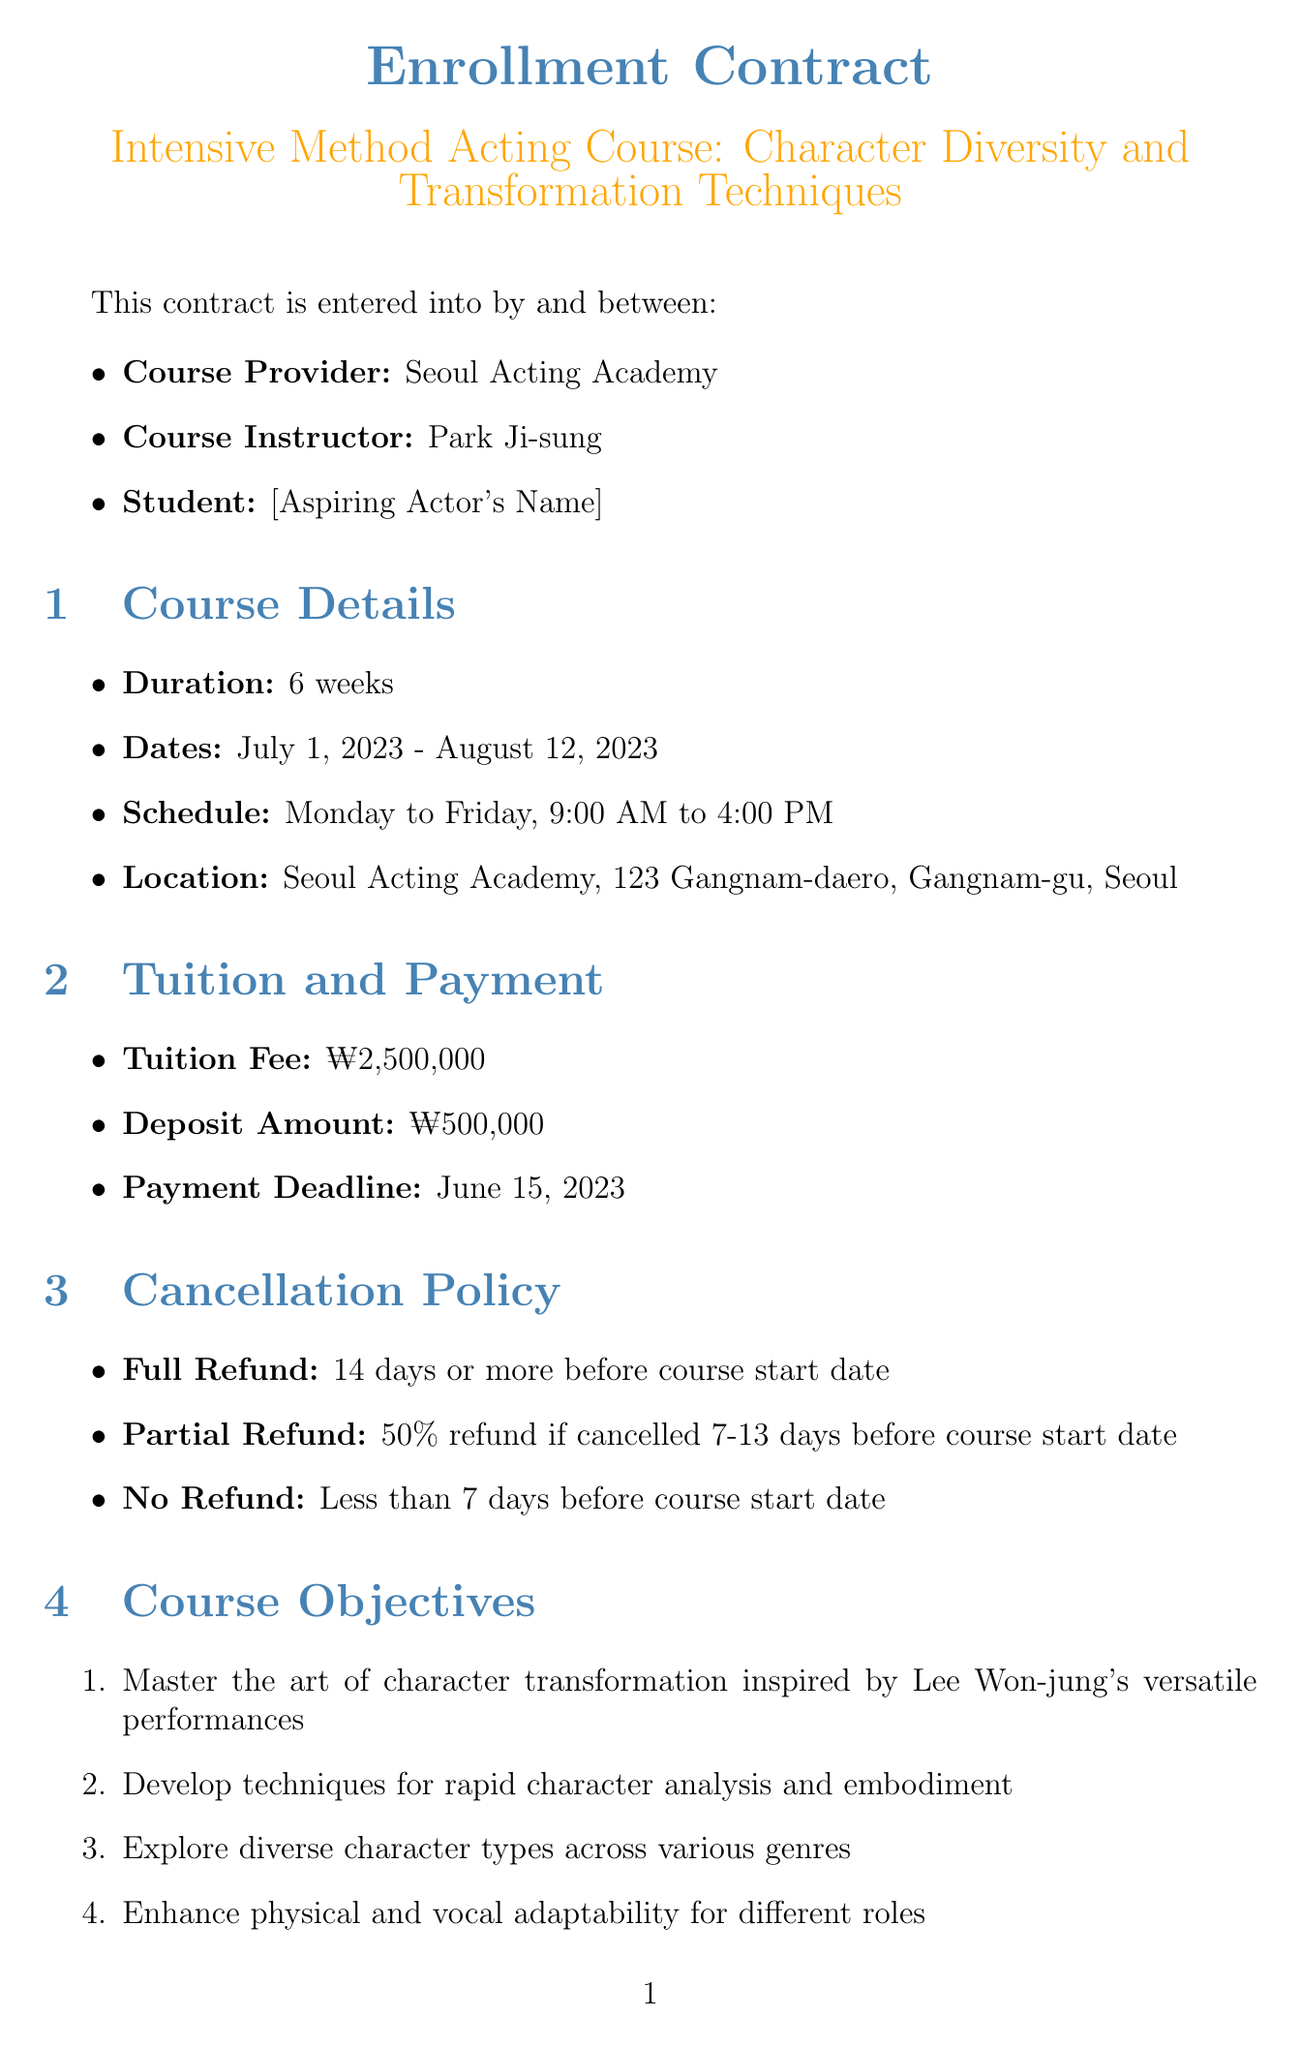What is the course provider? The document specifies that the course provider is the Seoul Acting Academy.
Answer: Seoul Acting Academy Who is the course instructor? The document indicates that the instructor for the course is Park Ji-sung.
Answer: Park Ji-sung What is the tuition fee for the course? According to the document, the tuition fee is ₩2,500,000.
Answer: ₩2,500,000 When does the course start? The document states that the course starts on July 1, 2023.
Answer: July 1, 2023 What is the cancellation policy for a full refund? The document mentions a full refund is available 14 days or more before the course start date.
Answer: 14 days or more before course start date What is one of the course objectives? The document lists several course objectives, one being to master character transformation inspired by Lee Won-jung's performances.
Answer: Master the art of character transformation inspired by Lee Won-jung's versatile performances How many weeks is the course duration? The document specifies that the course duration is 6 weeks.
Answer: 6 weeks What materials are required for the course? The document lists several materials, including comfortable clothing for movement exercises.
Answer: Comfortable clothing for movement exercises What is the minimum attendance required for course completion? According to the document, a minimum of 90% attendance is required.
Answer: 90% What certification will be awarded upon completion? The document states that students will receive a Certificate of Completion in Advanced Character Transformation Techniques.
Answer: Certificate of Completion in Advanced Character Transformation Techniques 